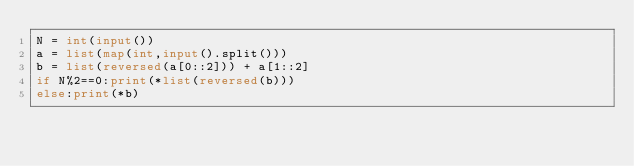<code> <loc_0><loc_0><loc_500><loc_500><_Python_>N = int(input())
a = list(map(int,input().split()))
b = list(reversed(a[0::2])) + a[1::2]
if N%2==0:print(*list(reversed(b)))
else:print(*b)</code> 